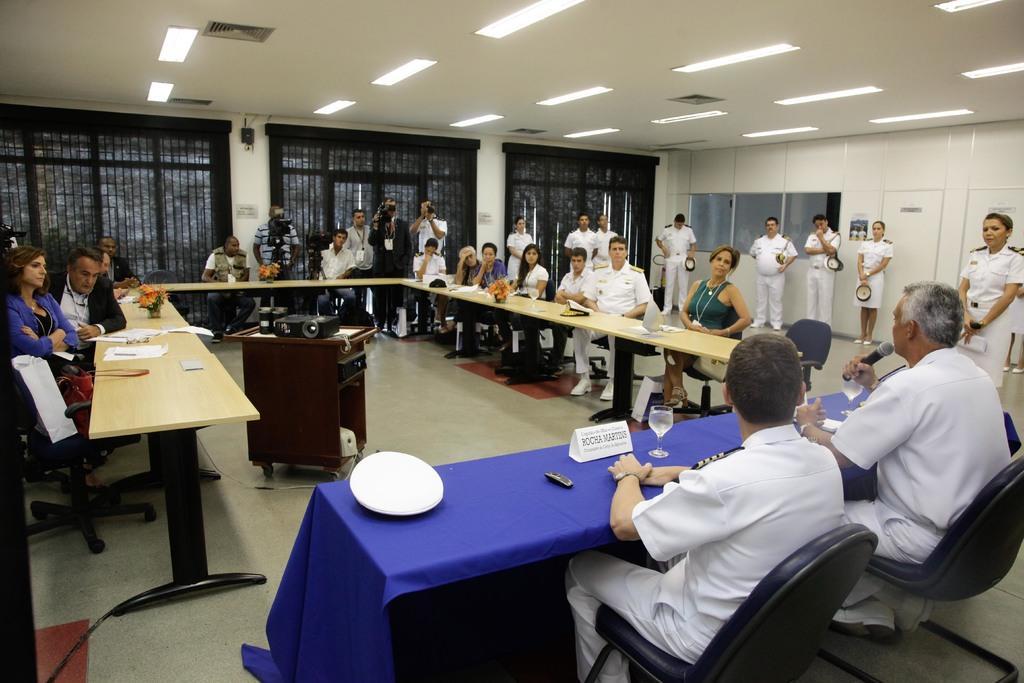In one or two sentences, can you explain what this image depicts? In the picture there is a conference room in which many people are sitting in a chair with the table in front of them some people are standing near to them on the table there are many things such as cap name plates glasses with the liquid flower vase on another table we can see an LED projector,there are many lights on the roof,some people are wearing a white costume. 